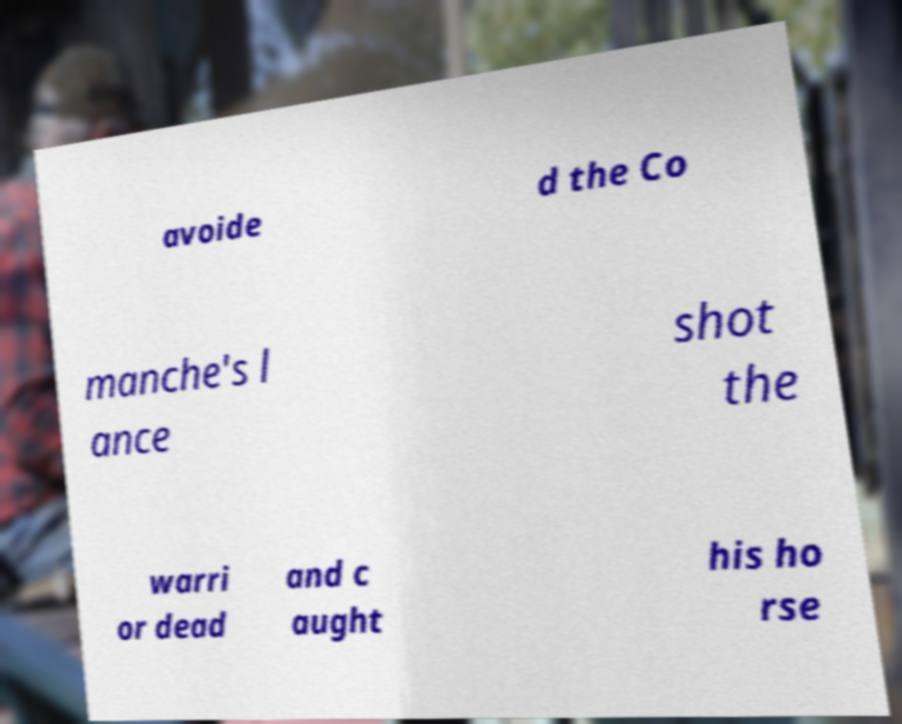Can you accurately transcribe the text from the provided image for me? avoide d the Co manche's l ance shot the warri or dead and c aught his ho rse 